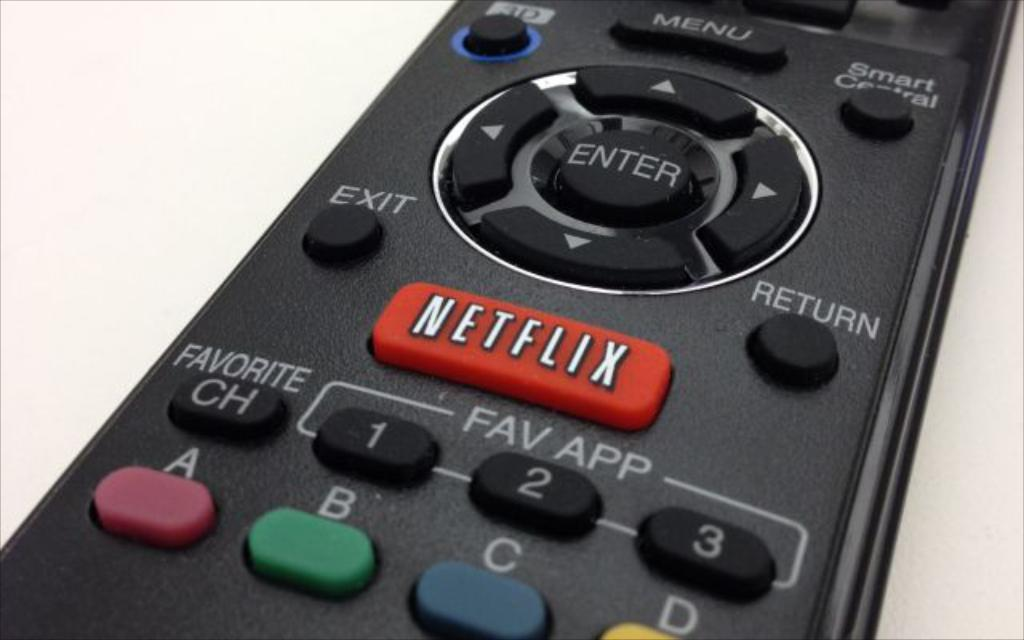Provide a one-sentence caption for the provided image. A remote control with A, B, C buttons as well as a Netflix button. 